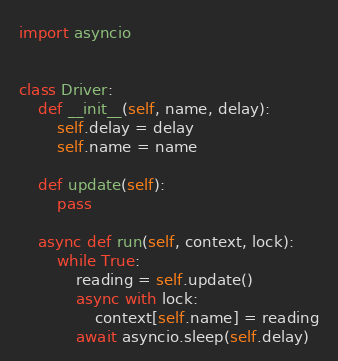Convert code to text. <code><loc_0><loc_0><loc_500><loc_500><_Python_>import asyncio


class Driver:
    def __init__(self, name, delay):
        self.delay = delay
        self.name = name

    def update(self):
        pass

    async def run(self, context, lock):
        while True:
            reading = self.update()
            async with lock:
                context[self.name] = reading
            await asyncio.sleep(self.delay)
</code> 